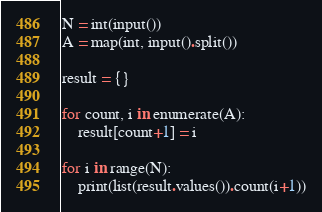Convert code to text. <code><loc_0><loc_0><loc_500><loc_500><_Python_>N = int(input())
A = map(int, input().split())

result = {}

for count, i in enumerate(A):
    result[count+1] = i

for i in range(N):
    print(list(result.values()).count(i+1))
</code> 